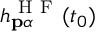<formula> <loc_0><loc_0><loc_500><loc_500>h _ { p \alpha } ^ { H F } ( t _ { 0 } )</formula> 